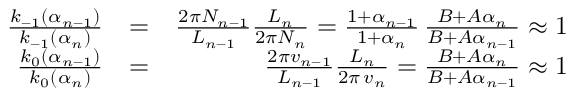<formula> <loc_0><loc_0><loc_500><loc_500>\begin{array} { r l r } { \frac { k _ { - 1 } ( \alpha _ { n - 1 } ) } { k _ { - 1 } ( \alpha _ { n } ) } } & { = } & { \frac { 2 \pi N _ { n - 1 } } { L _ { n - 1 } } \frac { L _ { n } } { 2 \pi N _ { n } } = \frac { 1 + \alpha _ { n - 1 } } { 1 + \alpha _ { n } } \, \frac { B + A \alpha _ { n } } { B + A \alpha _ { n - 1 } } \approx 1 } \\ { \frac { k _ { 0 } ( \alpha _ { n - 1 } ) } { k _ { 0 } ( \alpha _ { n } ) } } & { = } & { \frac { 2 \pi v _ { n - 1 } } { L _ { n - 1 } } \frac { L _ { n } } { 2 \pi \, v _ { n } } = \frac { B + A \alpha _ { n } } { B + A \alpha _ { n - 1 } } \approx 1 } \end{array}</formula> 